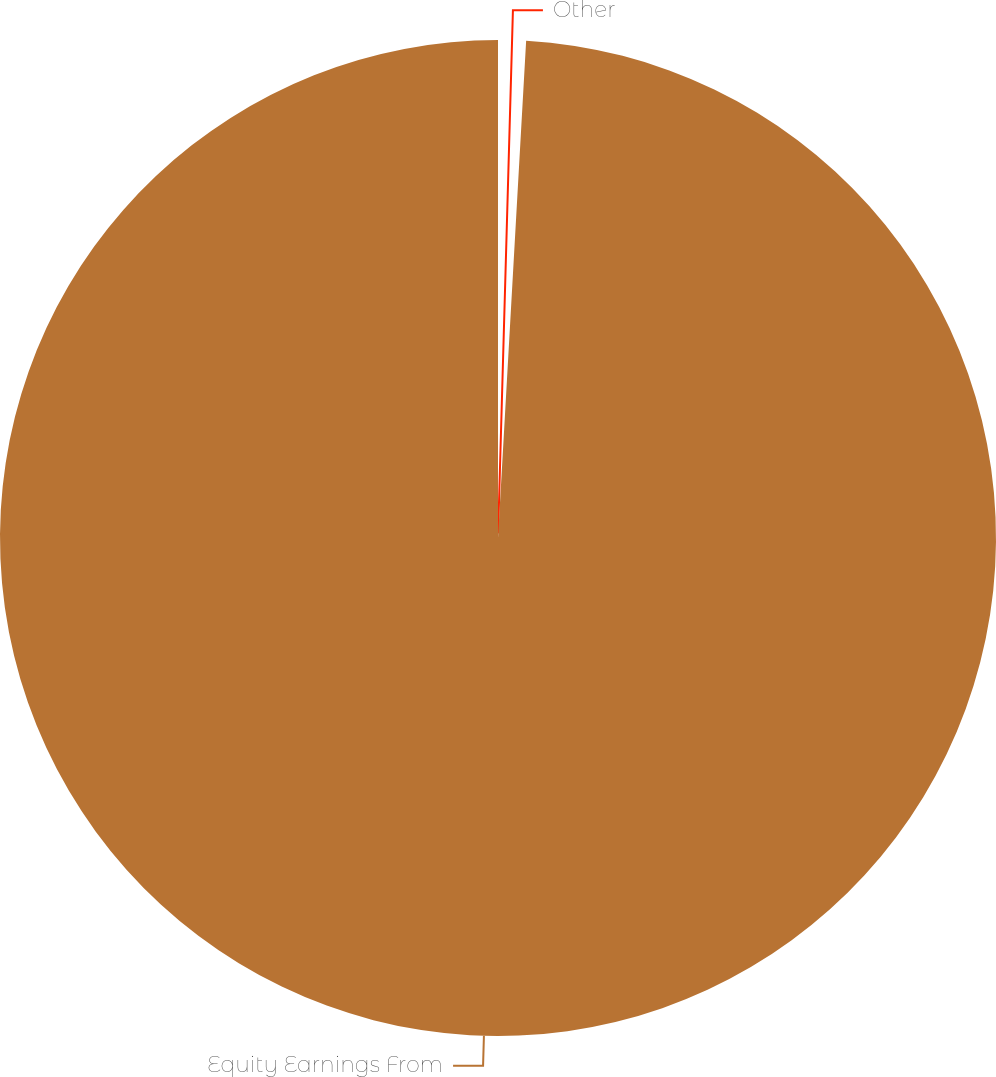<chart> <loc_0><loc_0><loc_500><loc_500><pie_chart><fcel>Other<fcel>Equity Earnings From<nl><fcel>0.9%<fcel>99.1%<nl></chart> 